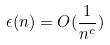Convert formula to latex. <formula><loc_0><loc_0><loc_500><loc_500>\epsilon ( n ) = O ( \frac { 1 } { n ^ { c } } )</formula> 